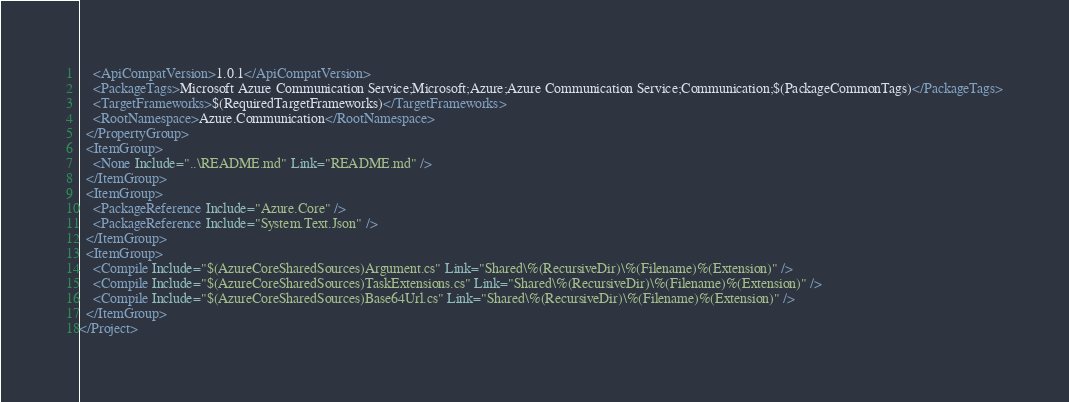<code> <loc_0><loc_0><loc_500><loc_500><_XML_>    <ApiCompatVersion>1.0.1</ApiCompatVersion>
    <PackageTags>Microsoft Azure Communication Service;Microsoft;Azure;Azure Communication Service;Communication;$(PackageCommonTags)</PackageTags>
    <TargetFrameworks>$(RequiredTargetFrameworks)</TargetFrameworks>
    <RootNamespace>Azure.Communication</RootNamespace>
  </PropertyGroup>
  <ItemGroup>
    <None Include="..\README.md" Link="README.md" />
  </ItemGroup>
  <ItemGroup>
    <PackageReference Include="Azure.Core" />
    <PackageReference Include="System.Text.Json" />
  </ItemGroup>
  <ItemGroup>
    <Compile Include="$(AzureCoreSharedSources)Argument.cs" Link="Shared\%(RecursiveDir)\%(Filename)%(Extension)" />
    <Compile Include="$(AzureCoreSharedSources)TaskExtensions.cs" Link="Shared\%(RecursiveDir)\%(Filename)%(Extension)" />
    <Compile Include="$(AzureCoreSharedSources)Base64Url.cs" Link="Shared\%(RecursiveDir)\%(Filename)%(Extension)" />
  </ItemGroup>
</Project>
</code> 